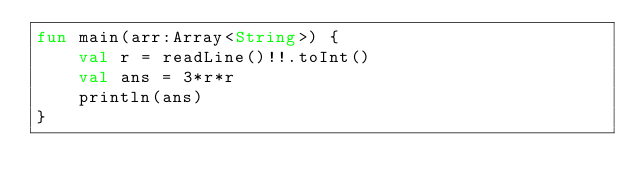Convert code to text. <code><loc_0><loc_0><loc_500><loc_500><_Kotlin_>fun main(arr:Array<String>) {
    val r = readLine()!!.toInt()
    val ans = 3*r*r
    println(ans)
}
</code> 